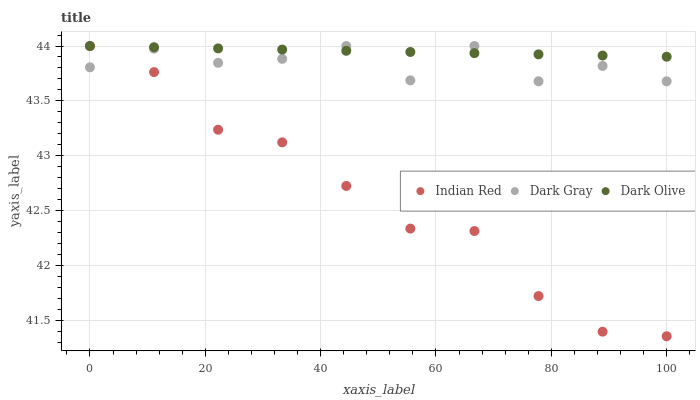Does Indian Red have the minimum area under the curve?
Answer yes or no. Yes. Does Dark Olive have the maximum area under the curve?
Answer yes or no. Yes. Does Dark Olive have the minimum area under the curve?
Answer yes or no. No. Does Indian Red have the maximum area under the curve?
Answer yes or no. No. Is Dark Olive the smoothest?
Answer yes or no. Yes. Is Dark Gray the roughest?
Answer yes or no. Yes. Is Indian Red the smoothest?
Answer yes or no. No. Is Indian Red the roughest?
Answer yes or no. No. Does Indian Red have the lowest value?
Answer yes or no. Yes. Does Dark Olive have the lowest value?
Answer yes or no. No. Does Indian Red have the highest value?
Answer yes or no. Yes. Does Indian Red intersect Dark Olive?
Answer yes or no. Yes. Is Indian Red less than Dark Olive?
Answer yes or no. No. Is Indian Red greater than Dark Olive?
Answer yes or no. No. 